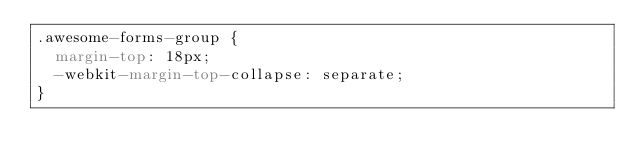Convert code to text. <code><loc_0><loc_0><loc_500><loc_500><_CSS_>.awesome-forms-group {
  margin-top: 18px;
  -webkit-margin-top-collapse: separate;
}
</code> 